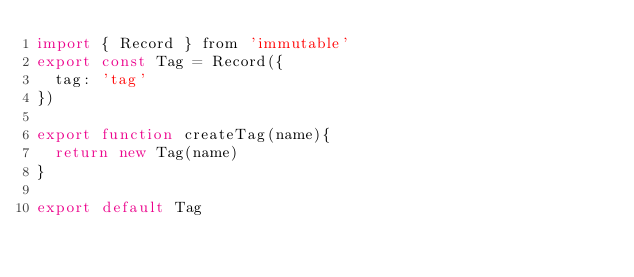Convert code to text. <code><loc_0><loc_0><loc_500><loc_500><_JavaScript_>import { Record } from 'immutable'
export const Tag = Record({
  tag: 'tag'
})

export function createTag(name){
  return new Tag(name)
}

export default Tag</code> 